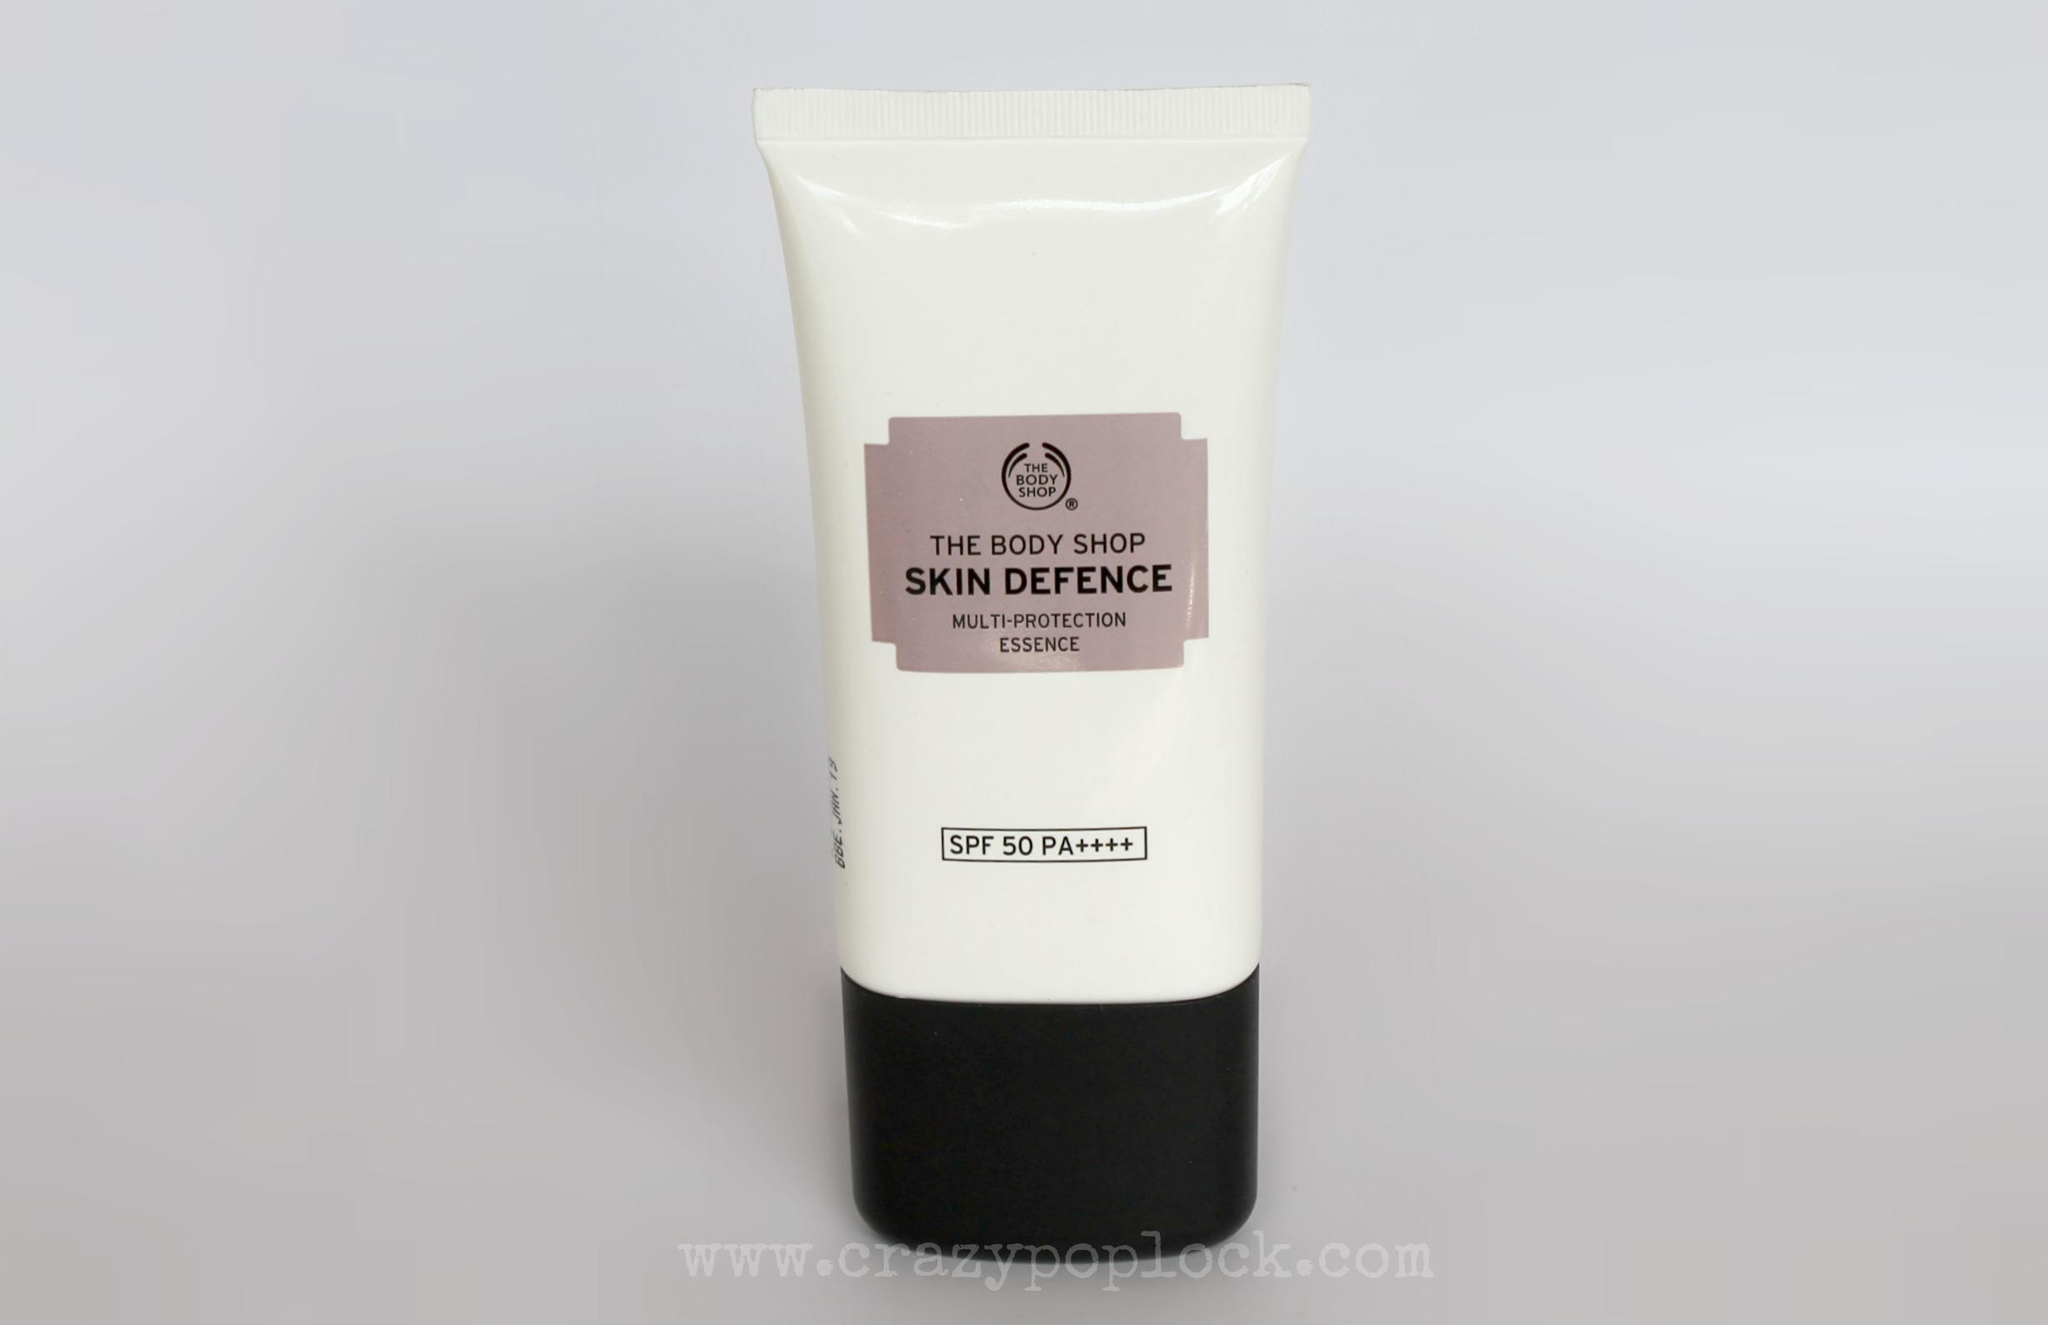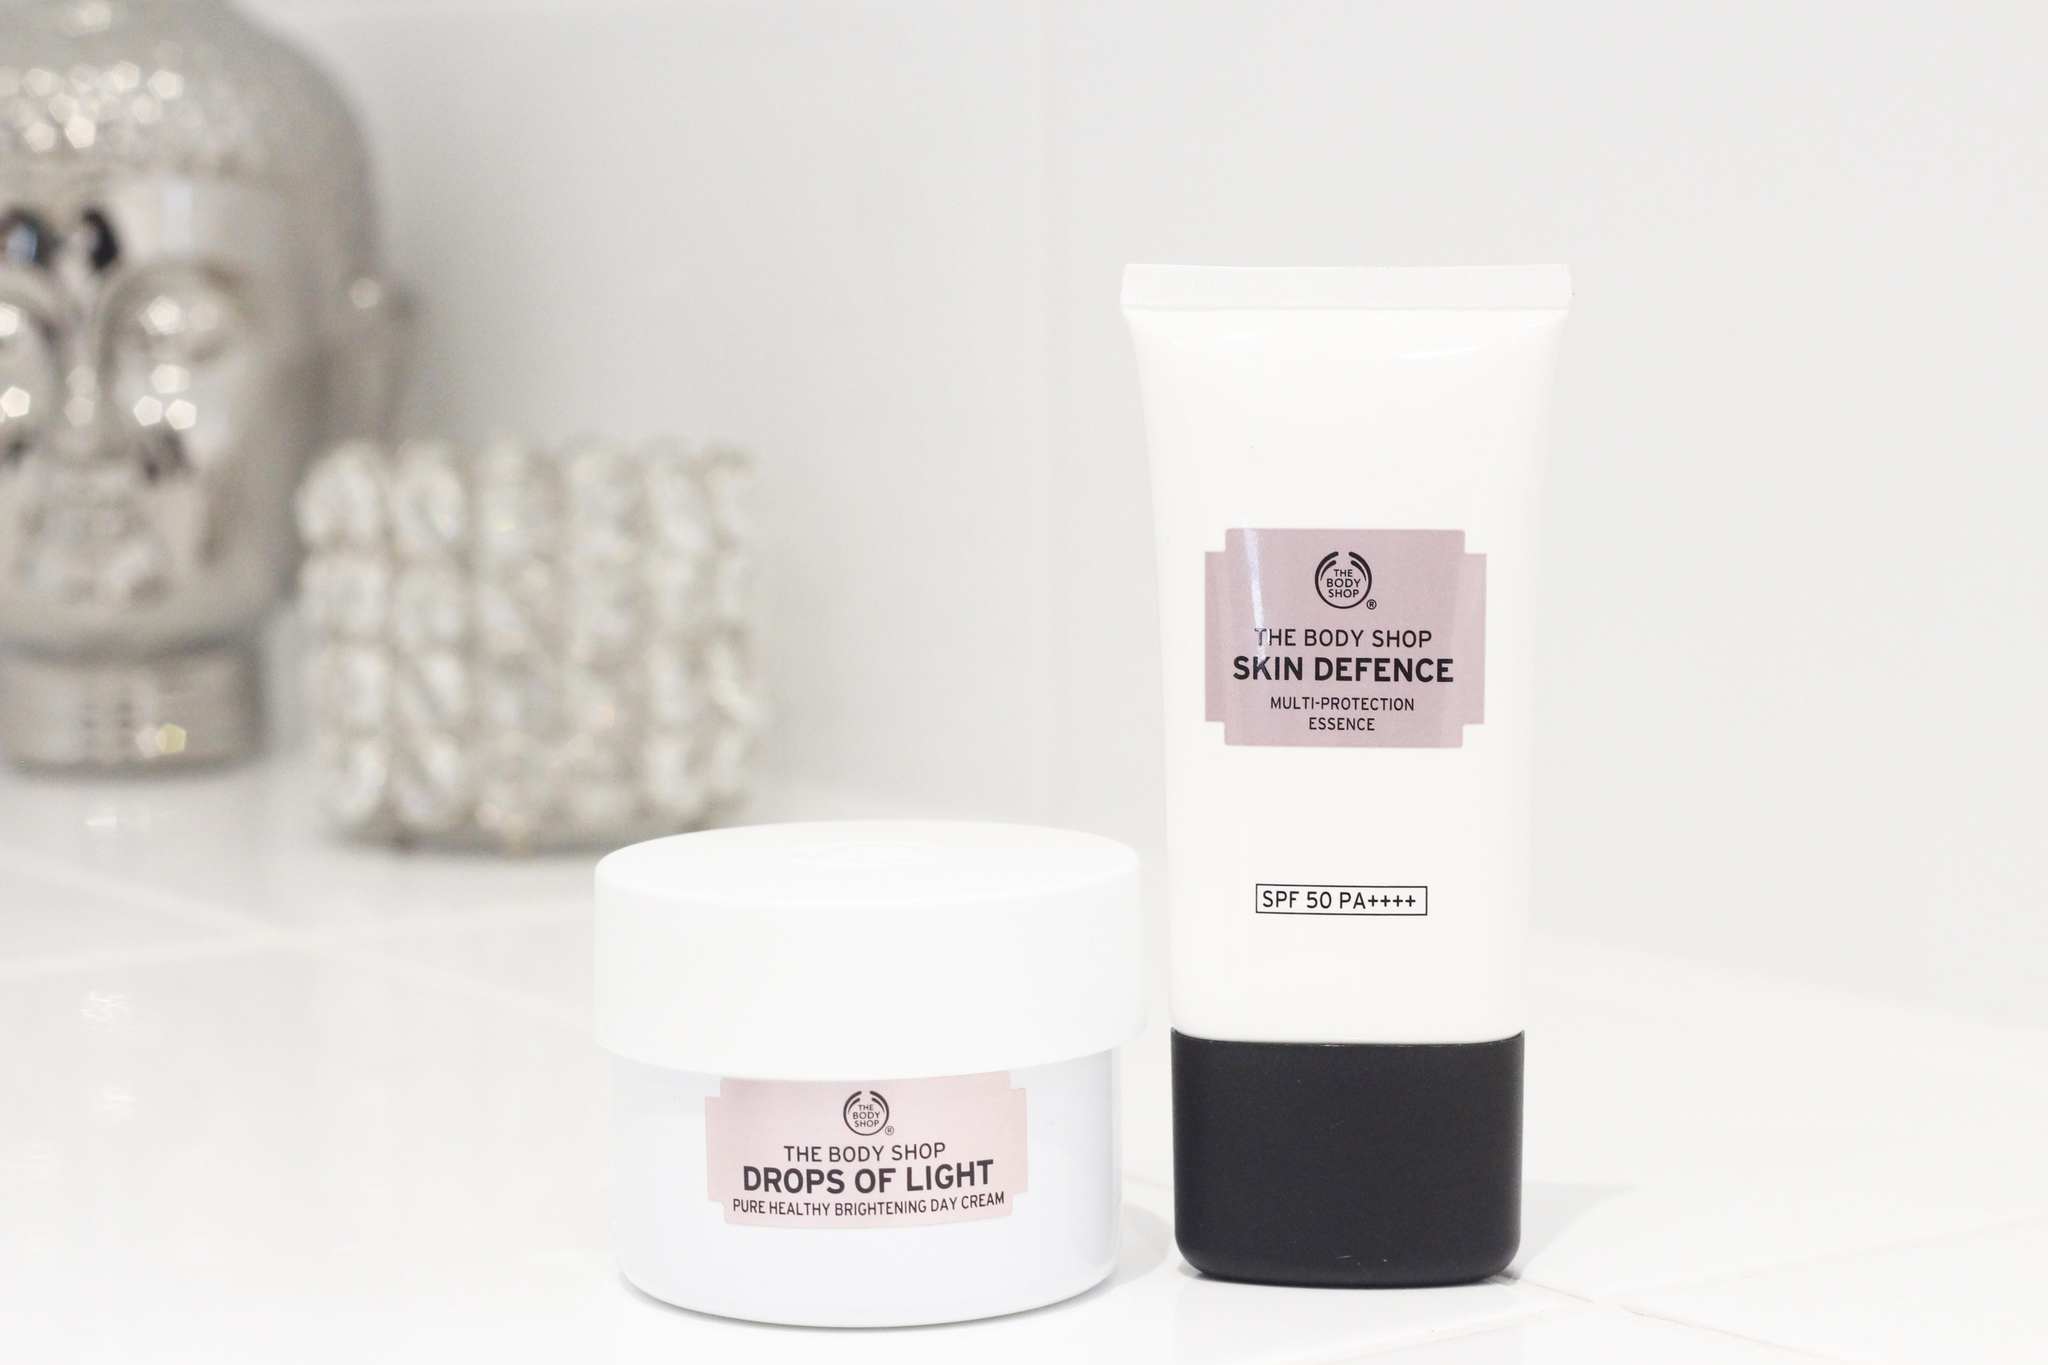The first image is the image on the left, the second image is the image on the right. Examine the images to the left and right. Is the description "Both tubes shown are standing upright." accurate? Answer yes or no. Yes. The first image is the image on the left, the second image is the image on the right. Given the left and right images, does the statement "There are four transparent round items filled with rosy-orange petal like colors." hold true? Answer yes or no. No. 